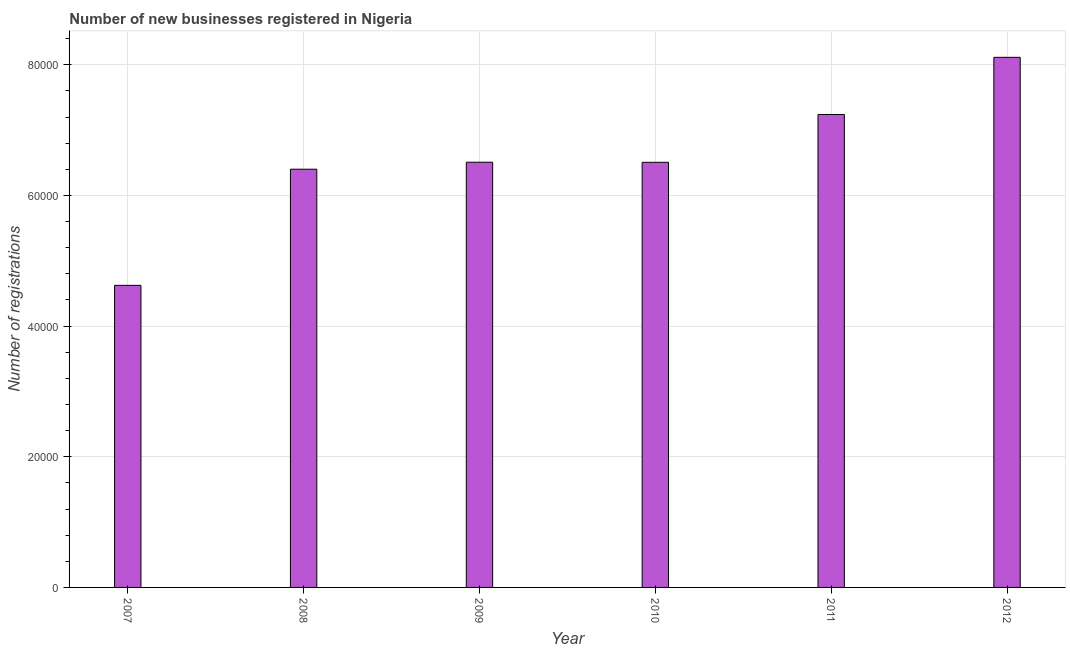Does the graph contain any zero values?
Your answer should be compact. No. Does the graph contain grids?
Your answer should be compact. Yes. What is the title of the graph?
Provide a short and direct response. Number of new businesses registered in Nigeria. What is the label or title of the X-axis?
Provide a succinct answer. Year. What is the label or title of the Y-axis?
Keep it short and to the point. Number of registrations. What is the number of new business registrations in 2008?
Give a very brief answer. 6.40e+04. Across all years, what is the maximum number of new business registrations?
Make the answer very short. 8.11e+04. Across all years, what is the minimum number of new business registrations?
Provide a succinct answer. 4.62e+04. In which year was the number of new business registrations maximum?
Offer a terse response. 2012. In which year was the number of new business registrations minimum?
Your answer should be compact. 2007. What is the sum of the number of new business registrations?
Your answer should be very brief. 3.94e+05. What is the difference between the number of new business registrations in 2007 and 2009?
Offer a very short reply. -1.88e+04. What is the average number of new business registrations per year?
Offer a very short reply. 6.57e+04. What is the median number of new business registrations?
Provide a succinct answer. 6.51e+04. Do a majority of the years between 2009 and 2012 (inclusive) have number of new business registrations greater than 36000 ?
Provide a succinct answer. Yes. What is the ratio of the number of new business registrations in 2010 to that in 2011?
Your answer should be very brief. 0.9. Is the number of new business registrations in 2010 less than that in 2012?
Provide a short and direct response. Yes. What is the difference between the highest and the second highest number of new business registrations?
Your answer should be very brief. 8748. What is the difference between the highest and the lowest number of new business registrations?
Make the answer very short. 3.49e+04. Are the values on the major ticks of Y-axis written in scientific E-notation?
Keep it short and to the point. No. What is the Number of registrations in 2007?
Ensure brevity in your answer.  4.62e+04. What is the Number of registrations of 2008?
Your response must be concise. 6.40e+04. What is the Number of registrations of 2009?
Provide a succinct answer. 6.51e+04. What is the Number of registrations in 2010?
Your answer should be compact. 6.51e+04. What is the Number of registrations in 2011?
Give a very brief answer. 7.24e+04. What is the Number of registrations of 2012?
Offer a very short reply. 8.11e+04. What is the difference between the Number of registrations in 2007 and 2008?
Keep it short and to the point. -1.78e+04. What is the difference between the Number of registrations in 2007 and 2009?
Offer a very short reply. -1.88e+04. What is the difference between the Number of registrations in 2007 and 2010?
Provide a short and direct response. -1.88e+04. What is the difference between the Number of registrations in 2007 and 2011?
Give a very brief answer. -2.62e+04. What is the difference between the Number of registrations in 2007 and 2012?
Offer a terse response. -3.49e+04. What is the difference between the Number of registrations in 2008 and 2009?
Your response must be concise. -1072. What is the difference between the Number of registrations in 2008 and 2010?
Your answer should be compact. -1057. What is the difference between the Number of registrations in 2008 and 2011?
Offer a terse response. -8379. What is the difference between the Number of registrations in 2008 and 2012?
Ensure brevity in your answer.  -1.71e+04. What is the difference between the Number of registrations in 2009 and 2011?
Your response must be concise. -7307. What is the difference between the Number of registrations in 2009 and 2012?
Give a very brief answer. -1.61e+04. What is the difference between the Number of registrations in 2010 and 2011?
Offer a very short reply. -7322. What is the difference between the Number of registrations in 2010 and 2012?
Make the answer very short. -1.61e+04. What is the difference between the Number of registrations in 2011 and 2012?
Make the answer very short. -8748. What is the ratio of the Number of registrations in 2007 to that in 2008?
Your answer should be very brief. 0.72. What is the ratio of the Number of registrations in 2007 to that in 2009?
Offer a terse response. 0.71. What is the ratio of the Number of registrations in 2007 to that in 2010?
Give a very brief answer. 0.71. What is the ratio of the Number of registrations in 2007 to that in 2011?
Keep it short and to the point. 0.64. What is the ratio of the Number of registrations in 2007 to that in 2012?
Provide a short and direct response. 0.57. What is the ratio of the Number of registrations in 2008 to that in 2011?
Keep it short and to the point. 0.88. What is the ratio of the Number of registrations in 2008 to that in 2012?
Ensure brevity in your answer.  0.79. What is the ratio of the Number of registrations in 2009 to that in 2010?
Your response must be concise. 1. What is the ratio of the Number of registrations in 2009 to that in 2011?
Your response must be concise. 0.9. What is the ratio of the Number of registrations in 2009 to that in 2012?
Ensure brevity in your answer.  0.8. What is the ratio of the Number of registrations in 2010 to that in 2011?
Your response must be concise. 0.9. What is the ratio of the Number of registrations in 2010 to that in 2012?
Make the answer very short. 0.8. What is the ratio of the Number of registrations in 2011 to that in 2012?
Provide a succinct answer. 0.89. 